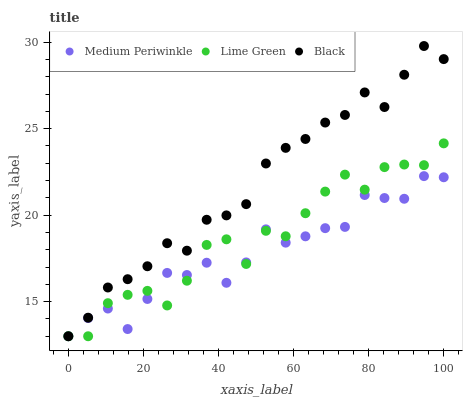Does Medium Periwinkle have the minimum area under the curve?
Answer yes or no. Yes. Does Black have the maximum area under the curve?
Answer yes or no. Yes. Does Black have the minimum area under the curve?
Answer yes or no. No. Does Medium Periwinkle have the maximum area under the curve?
Answer yes or no. No. Is Black the smoothest?
Answer yes or no. Yes. Is Lime Green the roughest?
Answer yes or no. Yes. Is Medium Periwinkle the smoothest?
Answer yes or no. No. Is Medium Periwinkle the roughest?
Answer yes or no. No. Does Lime Green have the lowest value?
Answer yes or no. Yes. Does Black have the highest value?
Answer yes or no. Yes. Does Medium Periwinkle have the highest value?
Answer yes or no. No. Does Black intersect Lime Green?
Answer yes or no. Yes. Is Black less than Lime Green?
Answer yes or no. No. Is Black greater than Lime Green?
Answer yes or no. No. 